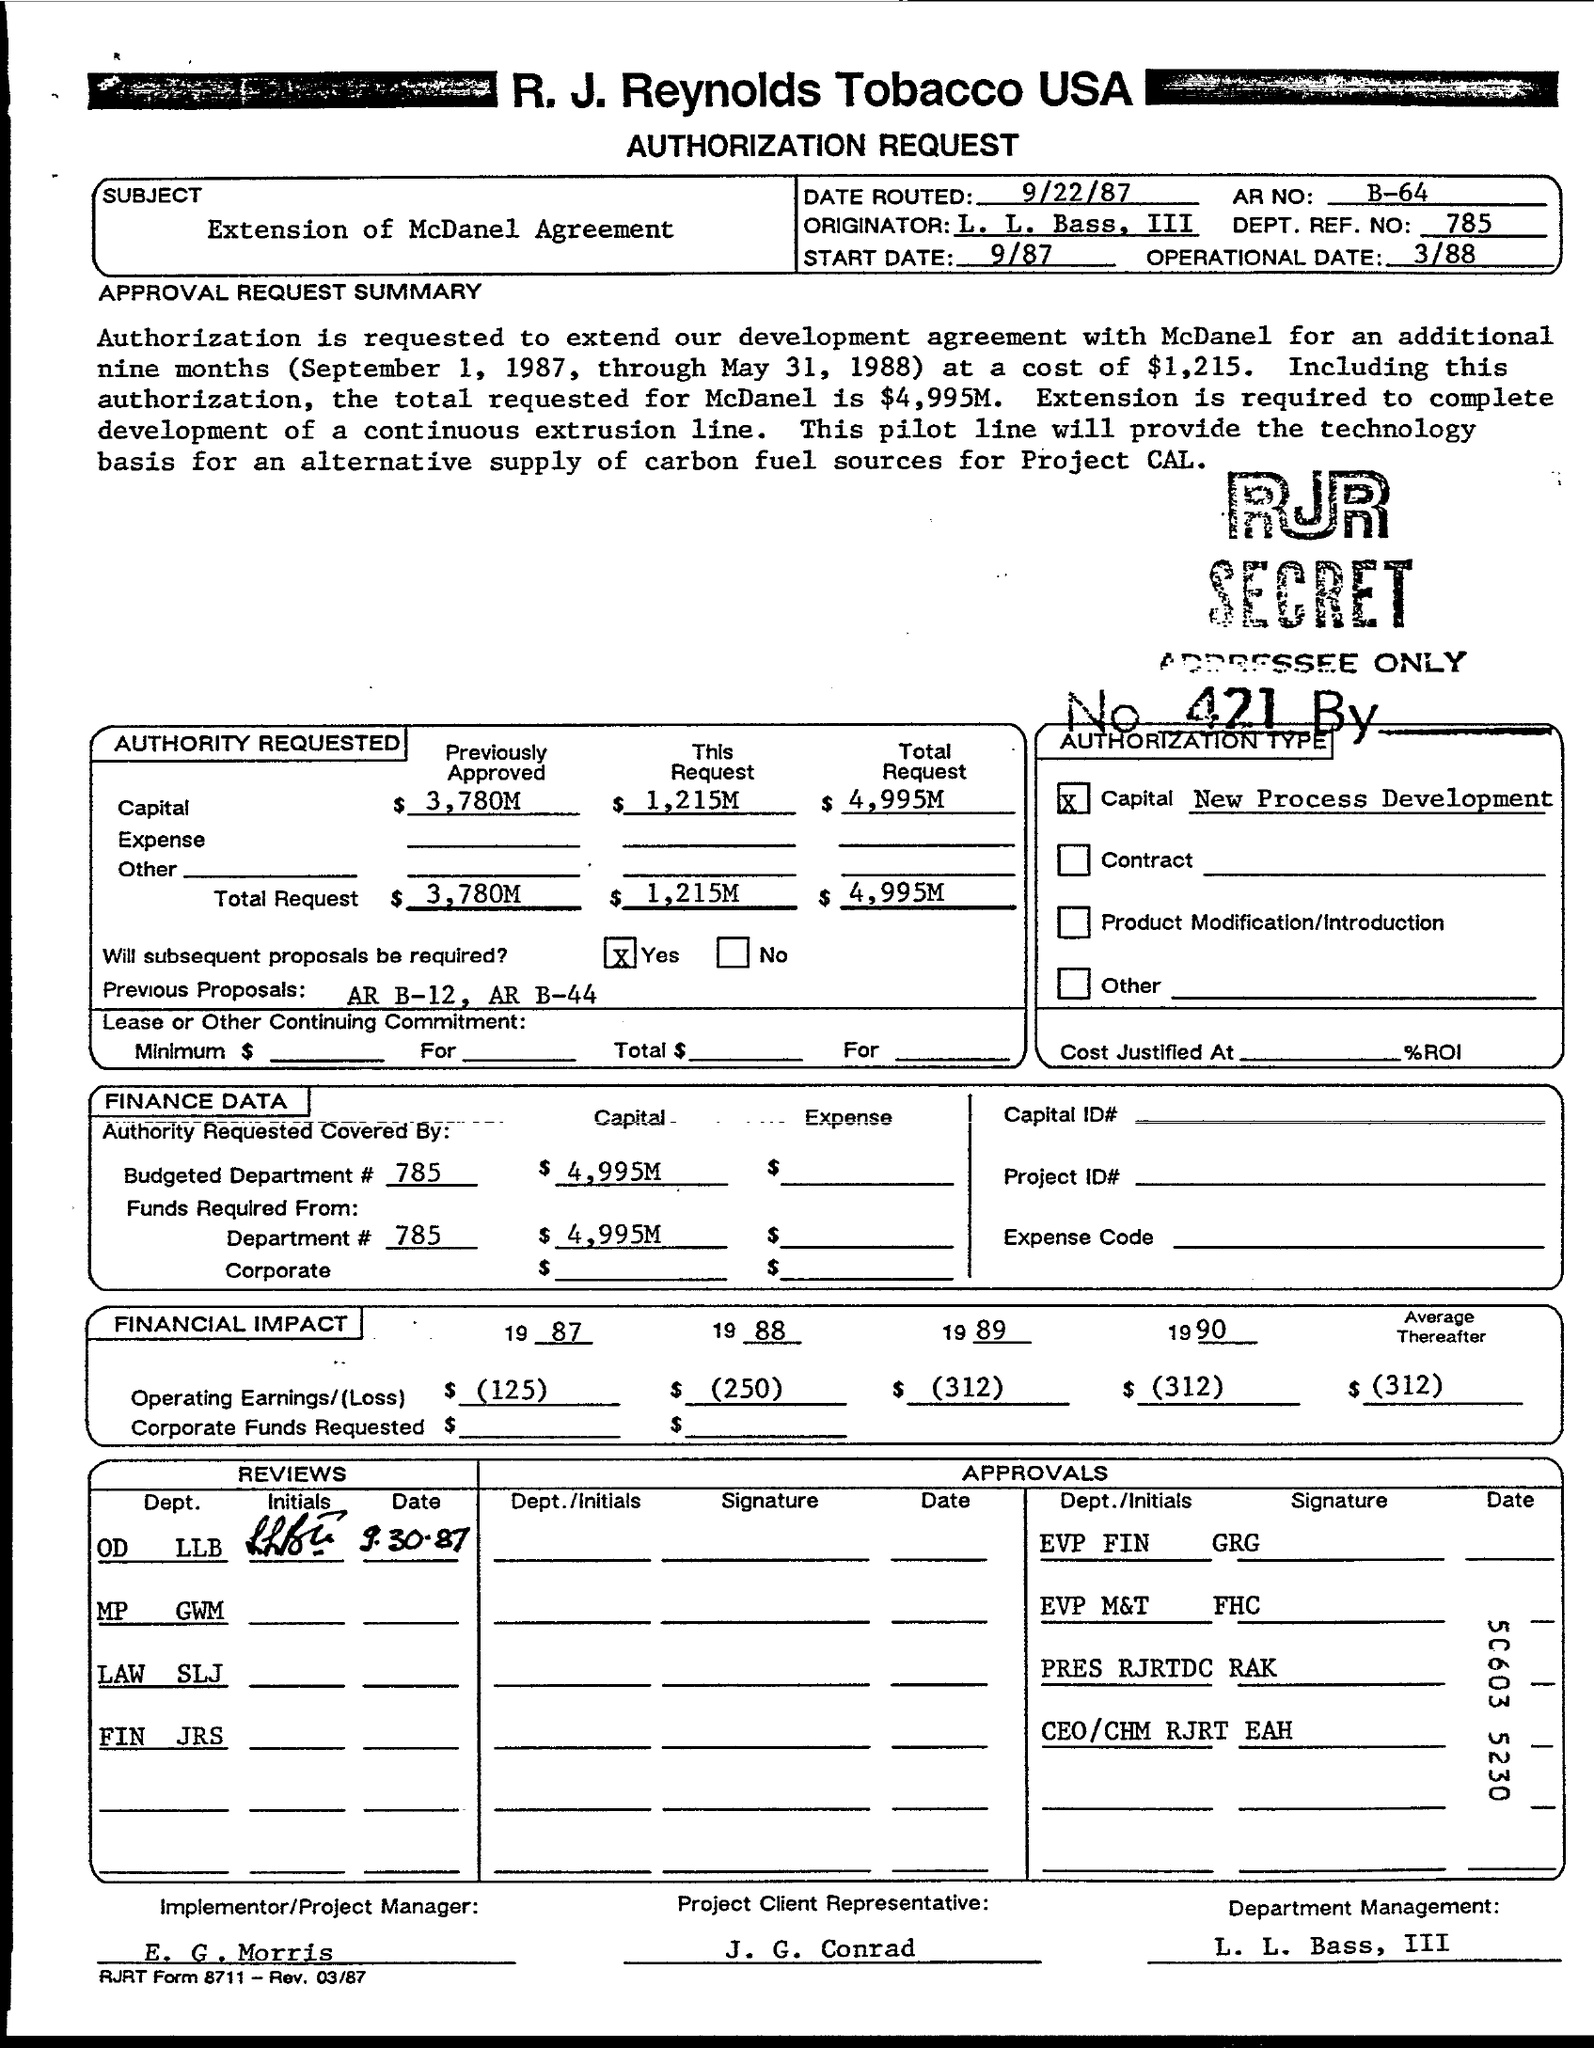Which Company's Authorization Request is this?
Make the answer very short. R. J. Reynolds Tobacco USA. What is the subject mentioned in this document?
Your response must be concise. Extension of McDanel Agreement. What is the Operational Date given in the document?
Give a very brief answer. 3/88. What is the DEPT. REF NO given in the document?
Provide a short and direct response. 785. What is the Total Request Capital given in the document?
Ensure brevity in your answer.  $ 4,995M. What is the Operating Earnings/(Loss) in the year 1988?
Your response must be concise. $ (250). What is the Operating Earnings/(Loss) in the year 1990?
Your answer should be very brief. (312). Who is the Project Client Representative as per the document?
Give a very brief answer. J. G. Conrad. 